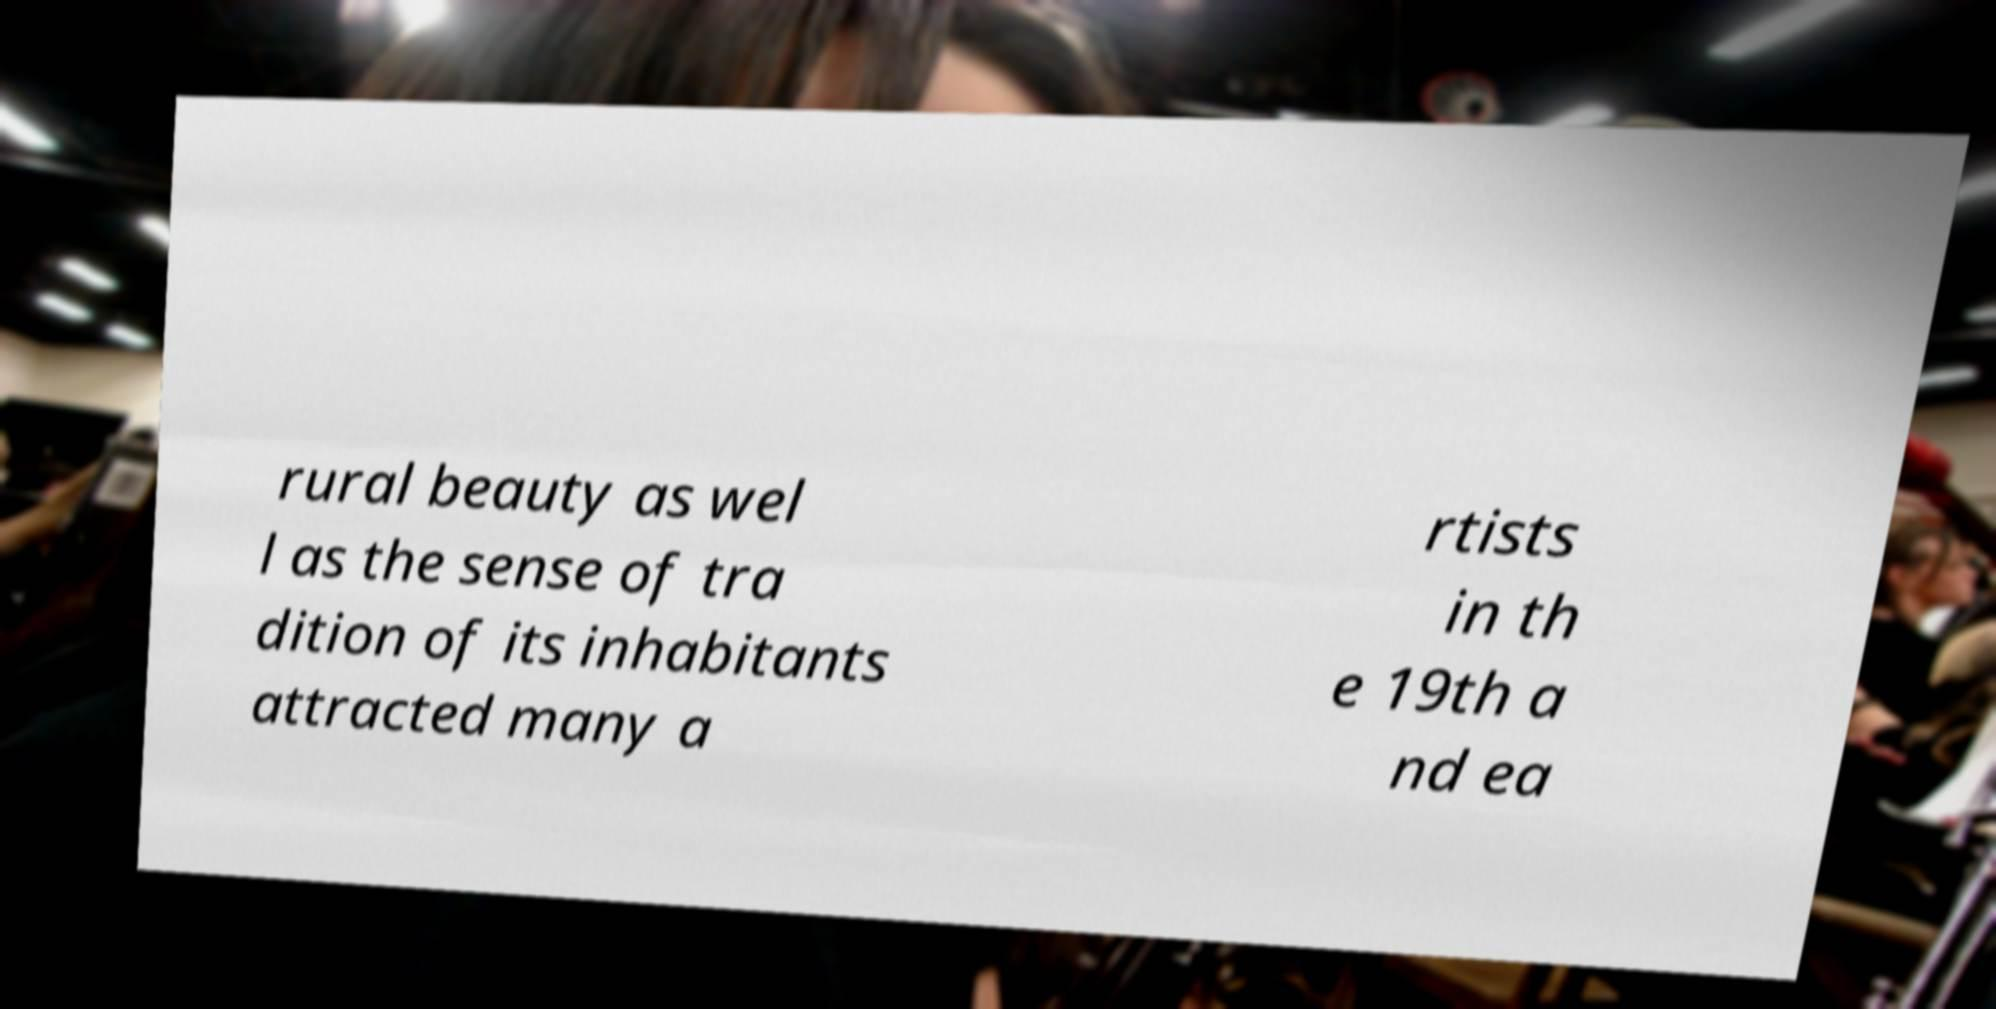What messages or text are displayed in this image? I need them in a readable, typed format. rural beauty as wel l as the sense of tra dition of its inhabitants attracted many a rtists in th e 19th a nd ea 